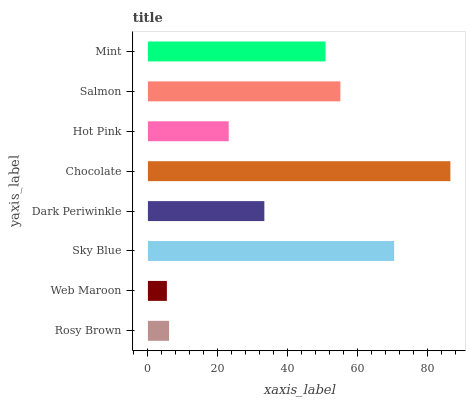Is Web Maroon the minimum?
Answer yes or no. Yes. Is Chocolate the maximum?
Answer yes or no. Yes. Is Sky Blue the minimum?
Answer yes or no. No. Is Sky Blue the maximum?
Answer yes or no. No. Is Sky Blue greater than Web Maroon?
Answer yes or no. Yes. Is Web Maroon less than Sky Blue?
Answer yes or no. Yes. Is Web Maroon greater than Sky Blue?
Answer yes or no. No. Is Sky Blue less than Web Maroon?
Answer yes or no. No. Is Mint the high median?
Answer yes or no. Yes. Is Dark Periwinkle the low median?
Answer yes or no. Yes. Is Salmon the high median?
Answer yes or no. No. Is Sky Blue the low median?
Answer yes or no. No. 